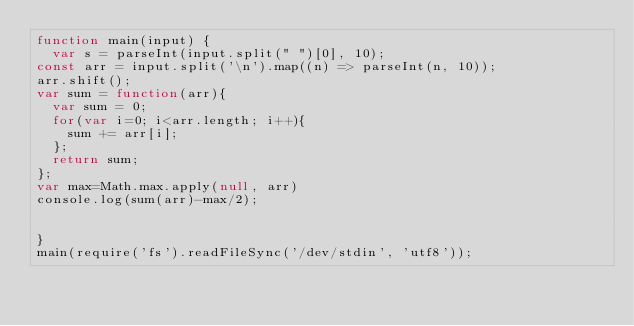<code> <loc_0><loc_0><loc_500><loc_500><_JavaScript_>function main(input) {
  var s = parseInt(input.split(" ")[0], 10);
const arr = input.split('\n').map((n) => parseInt(n, 10));
arr.shift();
var sum = function(arr){
  var sum = 0;
  for(var i=0; i<arr.length; i++){
    sum += arr[i];
  };
  return sum;
};
var max=Math.max.apply(null, arr)
console.log(sum(arr)-max/2);


}
main(require('fs').readFileSync('/dev/stdin', 'utf8'));</code> 